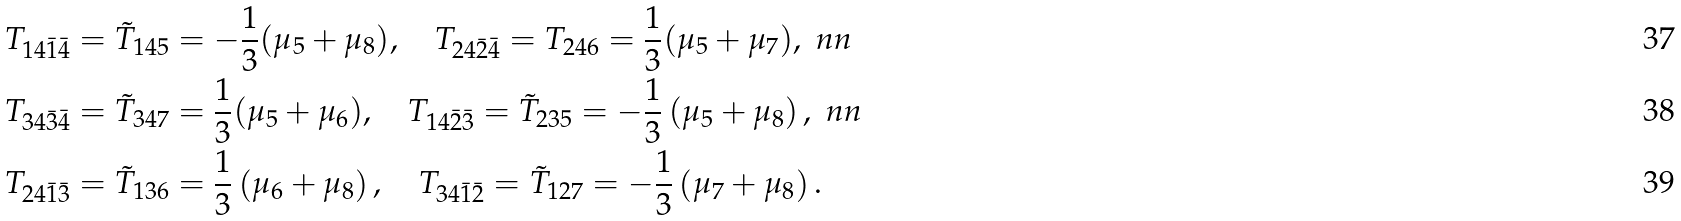Convert formula to latex. <formula><loc_0><loc_0><loc_500><loc_500>& T _ { 1 4 \bar { 1 } \bar { 4 } } = \tilde { T } _ { 1 4 5 } = - \frac { 1 } { 3 } ( \mu _ { 5 } + \mu _ { 8 } ) , \quad T _ { 2 4 \bar { 2 } \bar { 4 } } = T _ { 2 4 6 } = \frac { 1 } { 3 } ( \mu _ { 5 } + \mu _ { 7 } ) , \ n n \\ & T _ { 3 4 \bar { 3 } \bar { 4 } } = \tilde { T } _ { 3 4 7 } = \frac { 1 } { 3 } ( \mu _ { 5 } + \mu _ { 6 } ) , \quad T _ { 1 4 \bar { 2 } \bar { 3 } } = \tilde { T } _ { 2 3 5 } = - \frac { 1 } { 3 } \left ( \mu _ { 5 } + \mu _ { 8 } \right ) , \ n n \\ & T _ { 2 4 \bar { 1 } \bar { 3 } } = \tilde { T } _ { 1 3 6 } = \frac { 1 } { 3 } \left ( \mu _ { 6 } + \mu _ { 8 } \right ) , \quad T _ { 3 4 \bar { 1 } \bar { 2 } } = \tilde { T } _ { 1 2 7 } = - \frac { 1 } { 3 } \left ( \mu _ { 7 } + \mu _ { 8 } \right ) .</formula> 